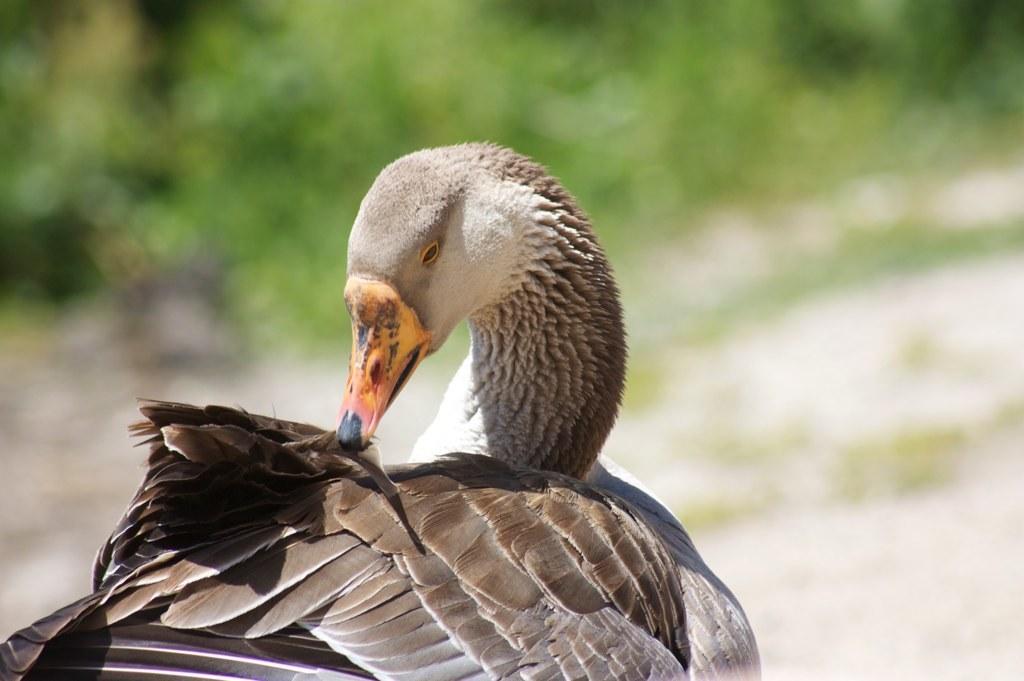Could you give a brief overview of what you see in this image? In this image we can see a bird and we can also see a blurred background. 